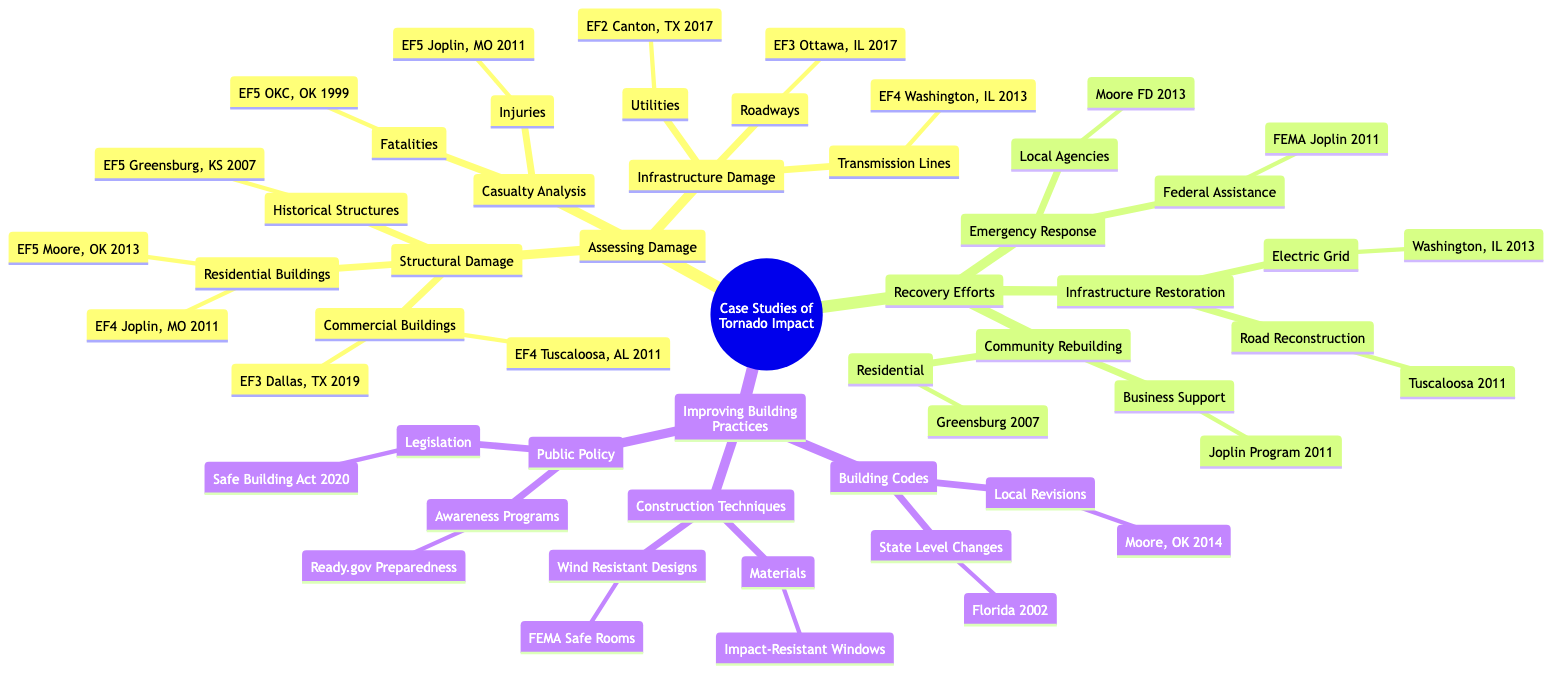What are the two EF5 tornado case studies listed under Residential Buildings? The diagram shows two EF5 tornado case studies under Residential Buildings: the EF5 Tornado in Moore, Oklahoma in 2013 and the EF5 Tornado in Joplin, Missouri in 2011.
Answer: EF5 Tornado in Moore, Oklahoma (2013), EF5 Tornado in Joplin, Missouri (2011) How many case studies are there for Commercial Buildings? The diagram indicates there are two case studies for Commercial Buildings: the EF4 Tornado in Tuscaloosa, Alabama in 2011 and the EF3 Tornado in Dallas, Texas in 2019. Therefore, the total number is two.
Answer: 2 What type of damage does the EF4 Washington, Illinois tornado relate to? The EF4 tornado in Washington, Illinois is related to Infrastructure Damage, specifically concerning Transmission Lines.
Answer: Transmission Lines Which tornado caused fatalities and what was its location? According to the diagram, the EF5 Tornado in Oklahoma City, Oklahoma in 1999 resulted in fatalities.
Answer: EF5 Tornado in Oklahoma City, Oklahoma (1999) What was the local agency involved in the emergency response for the Moore, Oklahoma tornado? The diagram lists the Moore Fire Department as the local agency involved in the emergency response for the tornado that occurred in 2013.
Answer: Moore Fire Department How many recovery effort categories are listed in the diagram? There are three recovery effort categories shown in the diagram: Emergency Response, Community Rebuilding, and Infrastructure Restoration. Thus, the total is three.
Answer: 3 What is one of the new building code revisions made after the tornado in Moore, Oklahoma? The diagram specifies that the building code revisions made in Moore, Oklahoma in 2014 are one of the changes aimed at improving building practices post-tornado.
Answer: Moore, Oklahoma Building Code Changes (2014) Which program supports business recovery in Joplin, Missouri and when was it established? The diagram indicates that the Joplin Business Recovery Program, established in 2011, supports business recovery following the tornado.
Answer: Joplin Business Recovery Program (2011) What does the Ortiz/Moreno Safe Building Act address? The Ortiz/Moreno Safe Building Act, mentioned in the diagram, addresses legislation related to improving building practices after tornado impacts.
Answer: Safe Building Act (2020) 